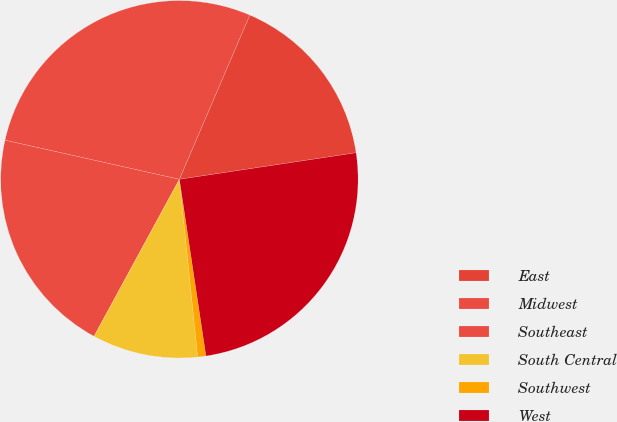<chart> <loc_0><loc_0><loc_500><loc_500><pie_chart><fcel>East<fcel>Midwest<fcel>Southeast<fcel>South Central<fcel>Southwest<fcel>West<nl><fcel>16.18%<fcel>27.94%<fcel>20.59%<fcel>9.56%<fcel>0.74%<fcel>25.0%<nl></chart> 